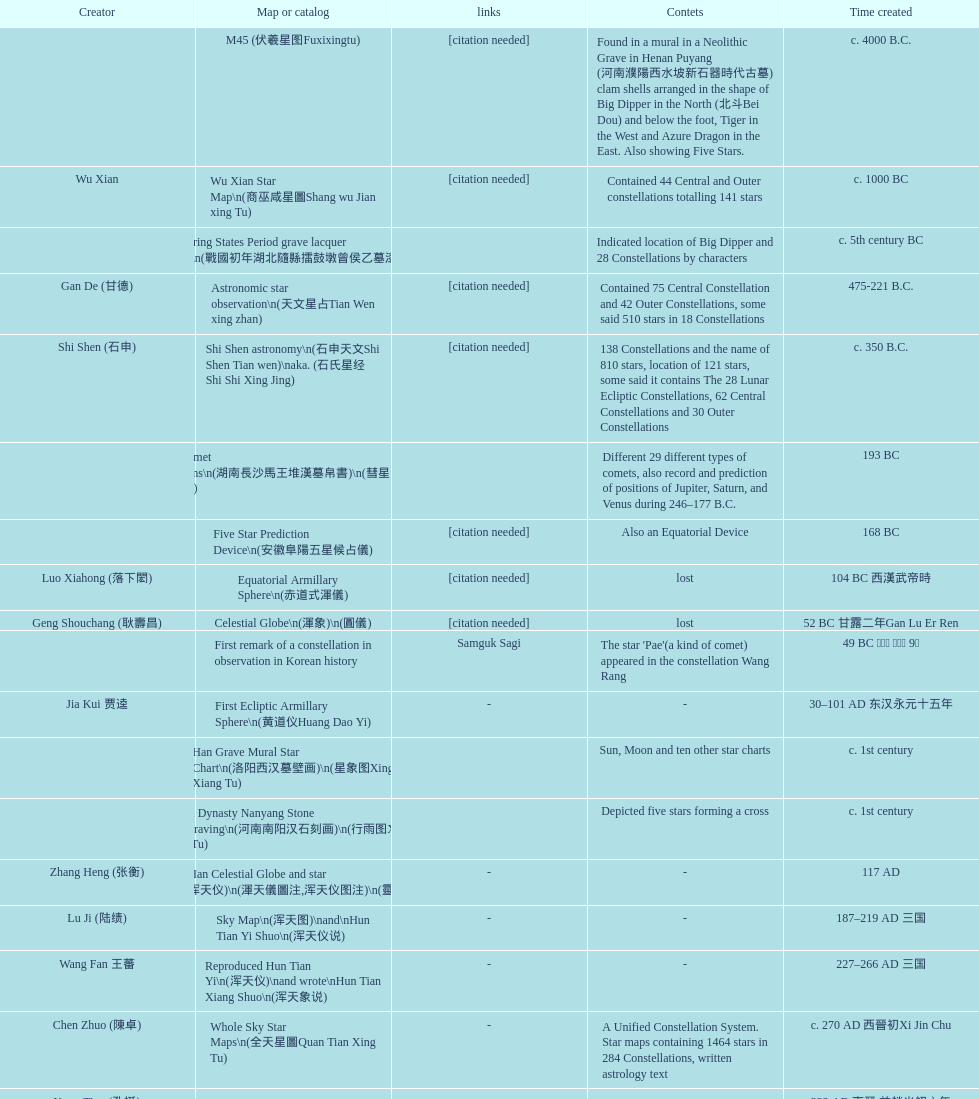Did xu guang ci or su song create the five star charts in 1094 ad? Su Song 蘇頌. 